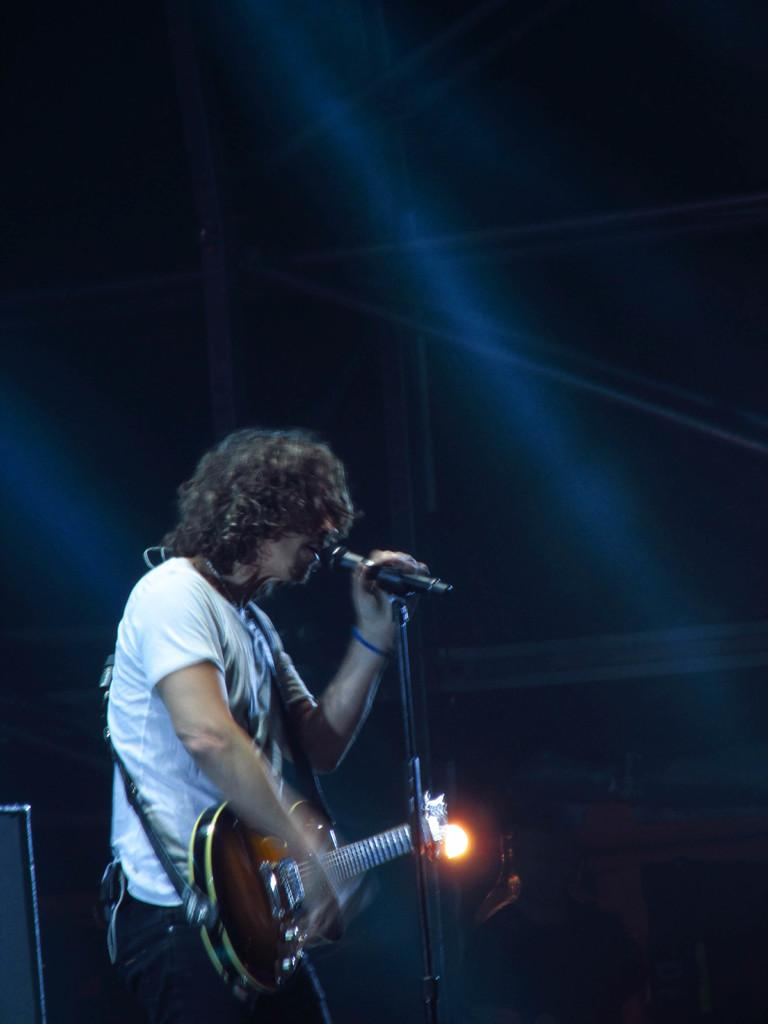What is the man in the image doing? The man is playing the guitar and singing on a microphone. What instrument is the man holding in the image? The man is holding a guitar in the image. Can you describe the lighting in the image? There is light in the background of the image. How would you describe the overall appearance of the image? The image appears to be dark. What type of board is the man using to play the guitar in the image? There is no board present in the image; the man is simply playing the guitar. What rhythm is the man playing on the guitar in the image? The image does not provide enough information to determine the rhythm the man is playing on the guitar. 